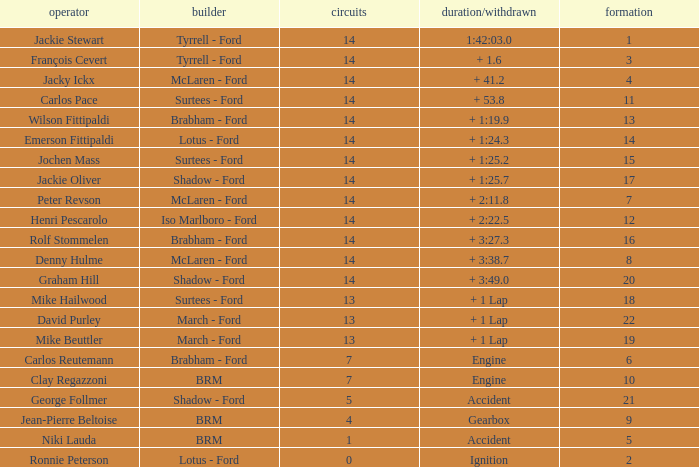What grad has a Time/Retired of + 1:24.3? 14.0. 